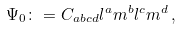<formula> <loc_0><loc_0><loc_500><loc_500>\Psi _ { 0 } \colon = C _ { a b c d } l ^ { a } m ^ { b } l ^ { c } m ^ { d } \, ,</formula> 